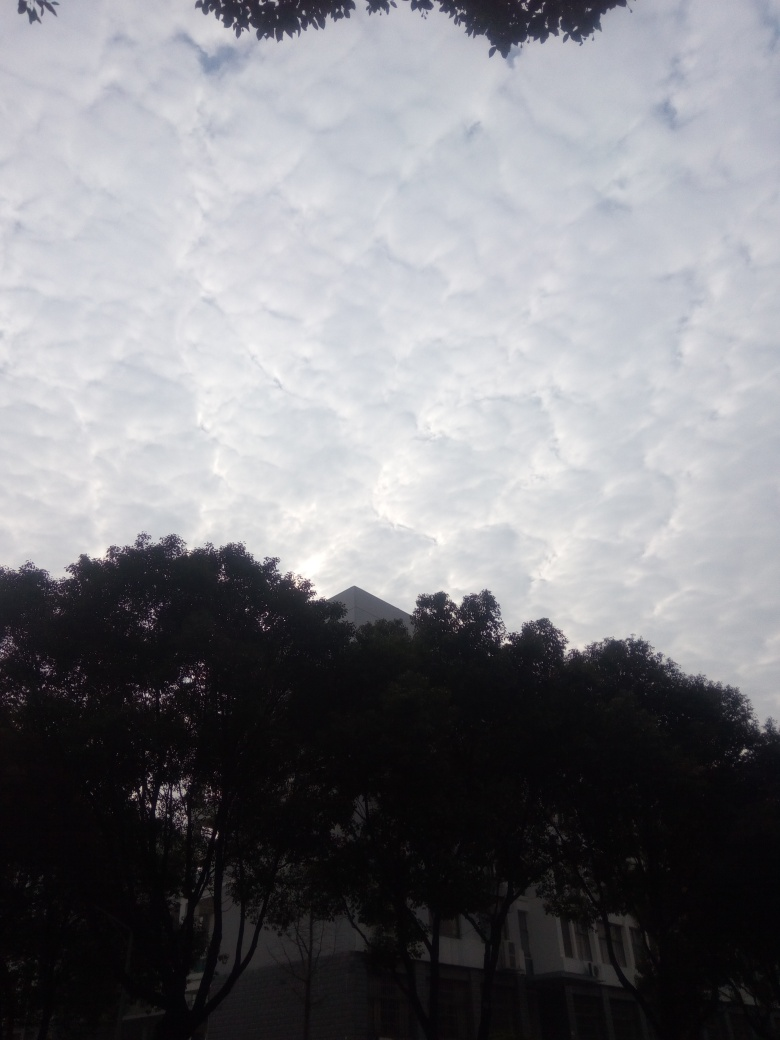What time of day does this photo seem to have been taken at, based on the lighting and sky? The photo appears to have been taken during the early morning or late afternoon, as suggested by the soft, diffused light, and the absence of harsh shadows. The clouds are well-lit, indicating that the sun is not at its peak, which typically occurs during midday. 